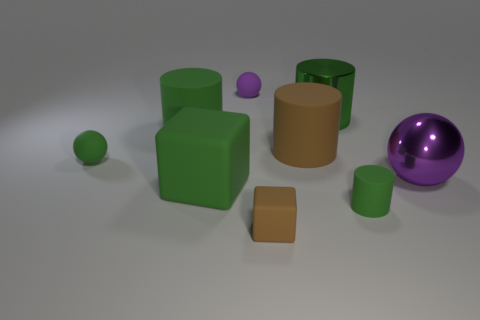There is a small green object right of the purple matte ball; what material is it?
Provide a short and direct response. Rubber. Is the number of tiny cylinders that are to the right of the big purple shiny sphere less than the number of big brown matte objects?
Your answer should be compact. Yes. Is the shape of the purple matte object the same as the big purple shiny thing?
Your answer should be compact. Yes. Is there anything else that has the same shape as the tiny purple rubber object?
Provide a succinct answer. Yes. Are there any small matte spheres?
Provide a succinct answer. Yes. Does the big purple shiny thing have the same shape as the brown object behind the brown block?
Offer a very short reply. No. There is a tiny ball that is to the right of the large rubber thing left of the big green cube; what is its material?
Your answer should be very brief. Rubber. The large cube is what color?
Give a very brief answer. Green. Do the rubber block behind the tiny cylinder and the matte cylinder on the right side of the big metallic cylinder have the same color?
Ensure brevity in your answer.  Yes. What size is the other rubber object that is the same shape as the small brown rubber thing?
Provide a short and direct response. Large. 